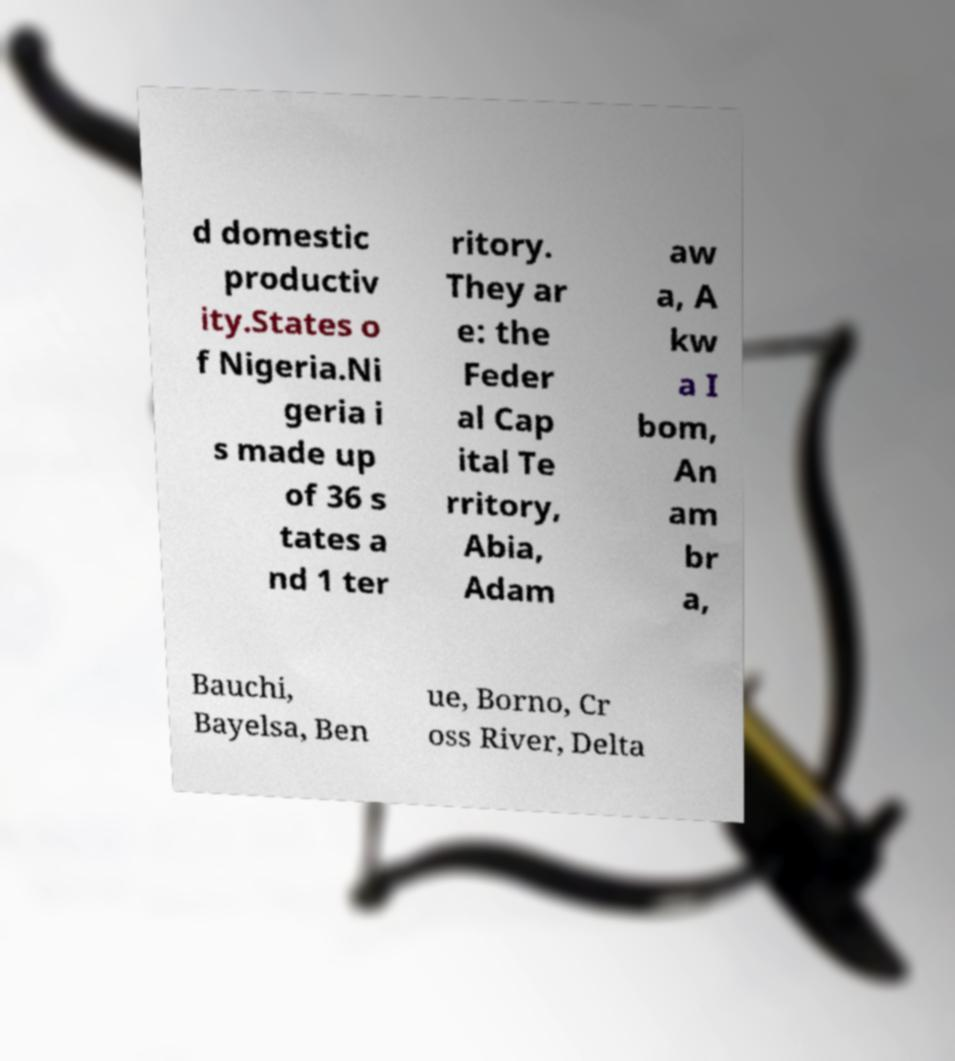Could you extract and type out the text from this image? d domestic productiv ity.States o f Nigeria.Ni geria i s made up of 36 s tates a nd 1 ter ritory. They ar e: the Feder al Cap ital Te rritory, Abia, Adam aw a, A kw a I bom, An am br a, Bauchi, Bayelsa, Ben ue, Borno, Cr oss River, Delta 